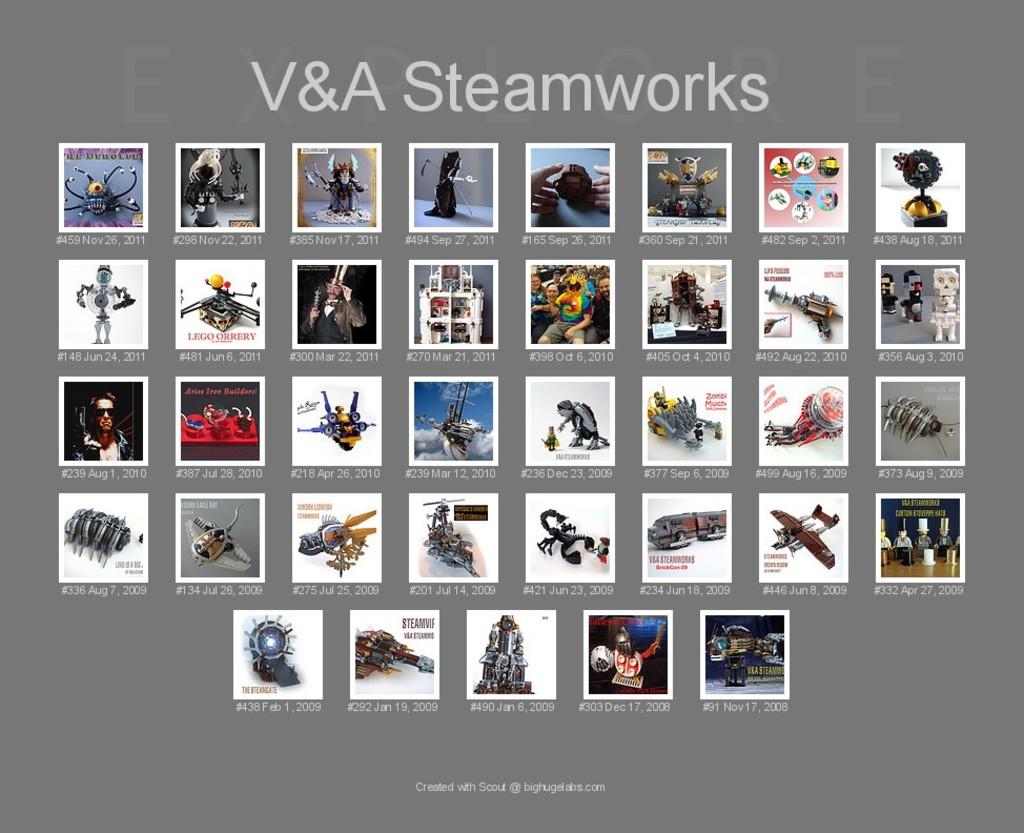Are these steamworks?
Your answer should be compact. Yes. 